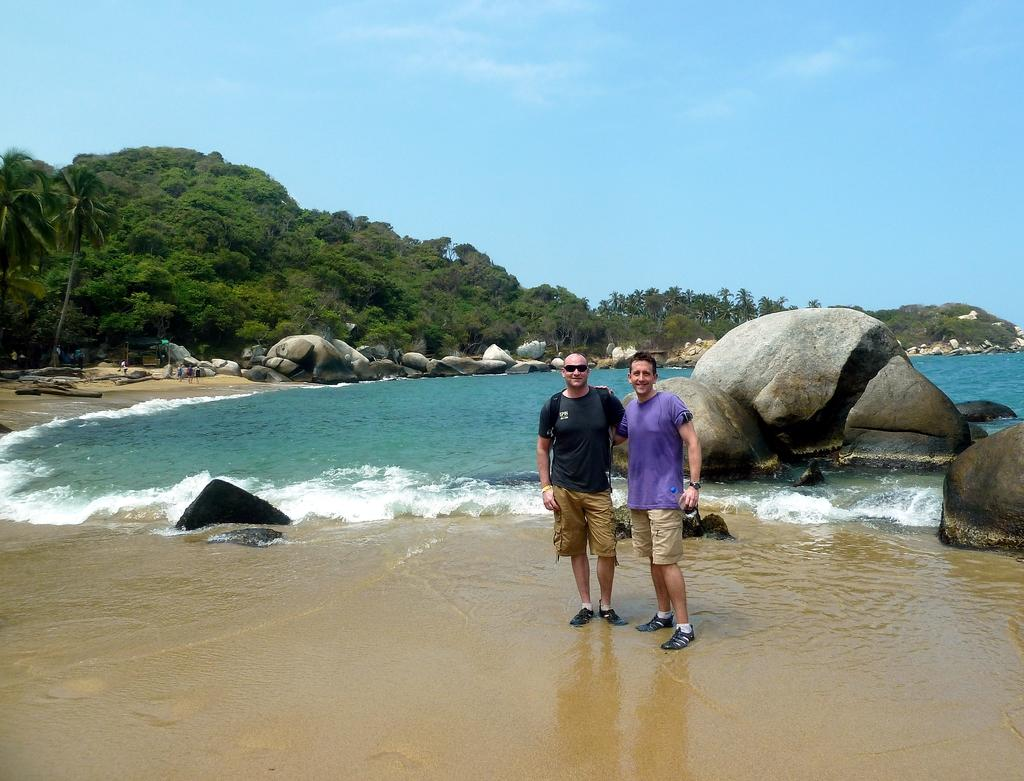How many people are in the image? There are two persons standing on the sand in the image. Can you describe one of the persons? One of the persons is wearing glasses. What type of natural elements can be seen in the image? There are rocks, water, trees, and the sky visible in the image. What color is the sheep in the image? There are no sheep present in the image. What type of marble is visible in the image? There is no marble present in the image. 